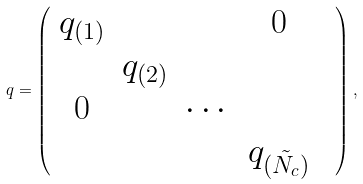Convert formula to latex. <formula><loc_0><loc_0><loc_500><loc_500>q = \left ( \begin{array} { c c c c c } q _ { ( 1 ) } & & & 0 & \\ & q _ { ( 2 ) } & & & \\ 0 & & \cdots & & \\ & & & q _ { ( \tilde { N } _ { c } ) } & \end{array} \right ) ,</formula> 